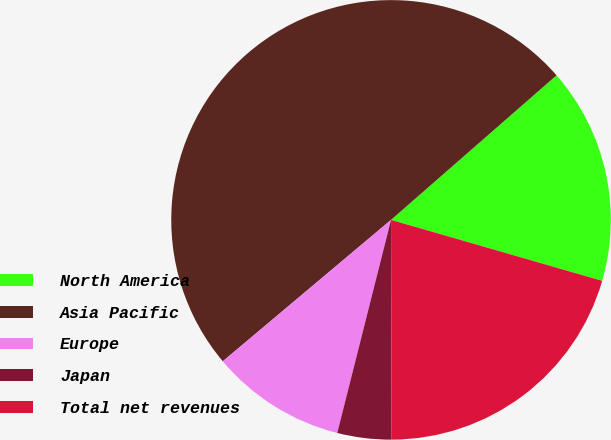Convert chart. <chart><loc_0><loc_0><loc_500><loc_500><pie_chart><fcel>North America<fcel>Asia Pacific<fcel>Europe<fcel>Japan<fcel>Total net revenues<nl><fcel>15.9%<fcel>49.7%<fcel>9.94%<fcel>3.98%<fcel>20.48%<nl></chart> 